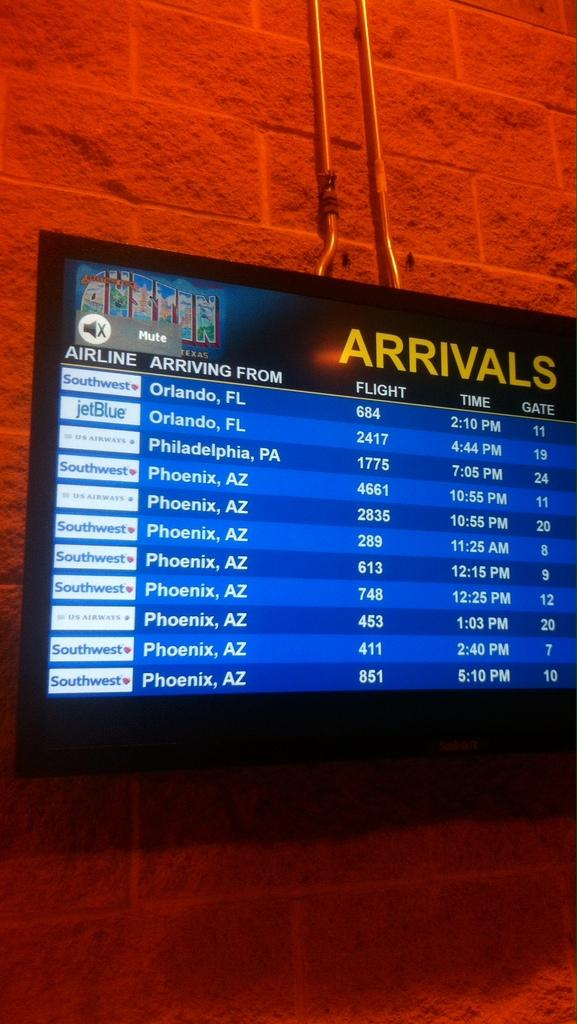Provide a one-sentence caption for the provided image. The flight schedule is displayed on the wall for arrival names, times and gates. 